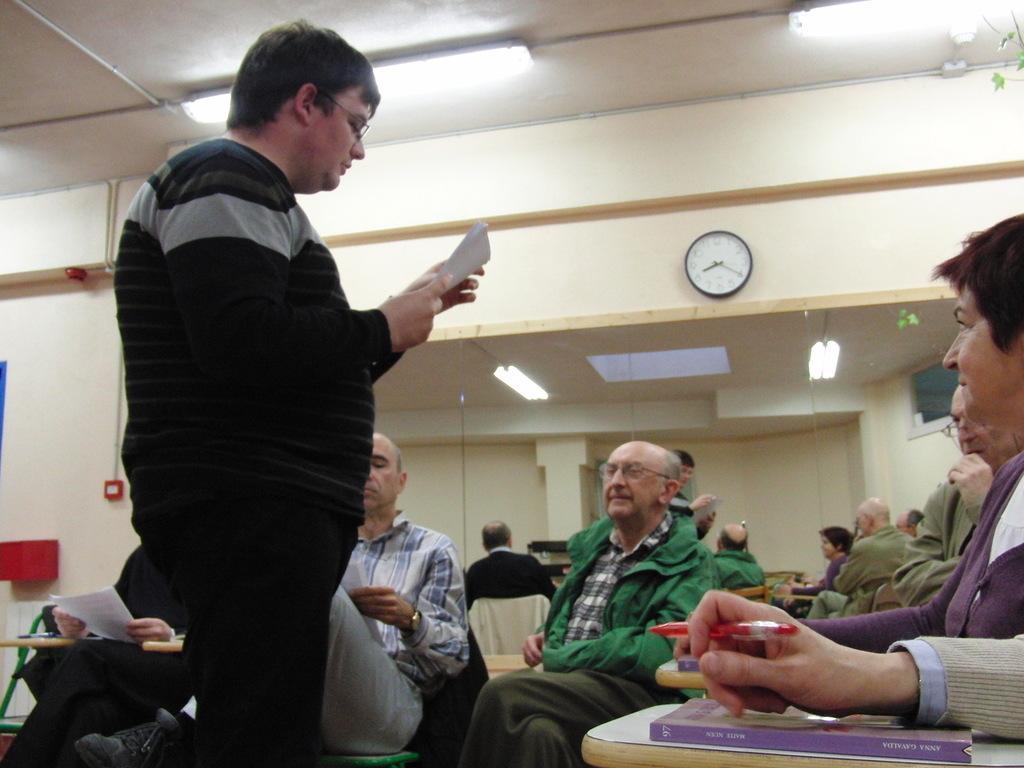Can you describe this image briefly? In this image we can see men sitting on the chairs and some are standing on the floor. On the chairs there are books and pens. In the background we can see electric lights, walls, pipelines, switches and a clock attached to the wall. 